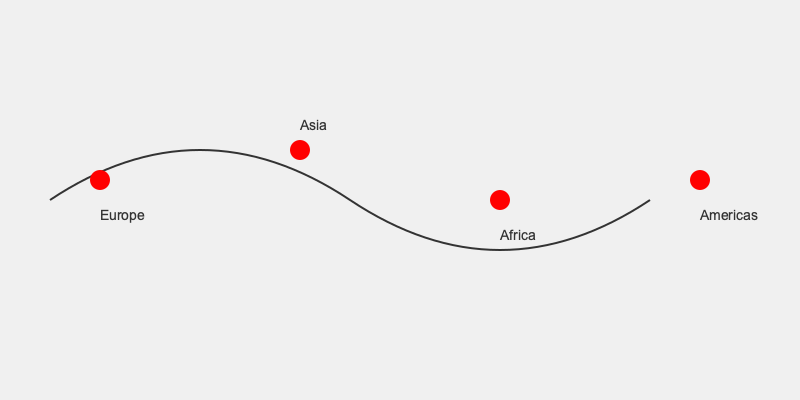Based on the world map representation shown, which region appears to have the highest concentration of World Heritage sites, and how might this distribution impact global perspectives on cultural and natural heritage? To answer this question, let's analyze the map and consider its implications step-by-step:

1. Map analysis:
   - The map shows four regions: Europe, Asia, Africa, and the Americas.
   - Each region is represented by a red circle, presumably indicating the concentration of World Heritage sites.

2. Concentration comparison:
   - Europe's circle is positioned highest on the curve, suggesting the highest concentration of sites.
   - Asia follows closely, with its circle also relatively high on the curve.
   - Africa and the Americas have circles lower on the curve, indicating fewer sites.

3. Historical context:
   - Europe's high concentration can be attributed to its long recorded history, numerous ancient civilizations, and early involvement in the World Heritage program.

4. Impact on global perspectives:
   - This distribution may lead to a Eurocentric view of world heritage.
   - It could result in underrepresentation of cultural and natural heritage from other regions.
   - This imbalance might influence global tourism patterns and cultural education.

5. Implications for heritage preservation:
   - Regions with fewer recognized sites might receive less attention and resources for preservation.
   - There may be a need for increased efforts to identify and nominate sites in underrepresented regions.

6. Educational considerations:
   - As a history teacher, this distribution highlights the importance of presenting a balanced view of world heritage in curricula.
   - It provides an opportunity to discuss the factors influencing site recognition and the need for diverse representation.

Based on this analysis, Europe appears to have the highest concentration of World Heritage sites, which can significantly impact global perspectives on cultural and natural heritage by potentially skewing attention and resources towards European sites while underrepresenting other regions' contributions to world heritage.
Answer: Europe; potential Eurocentric bias in global heritage recognition 